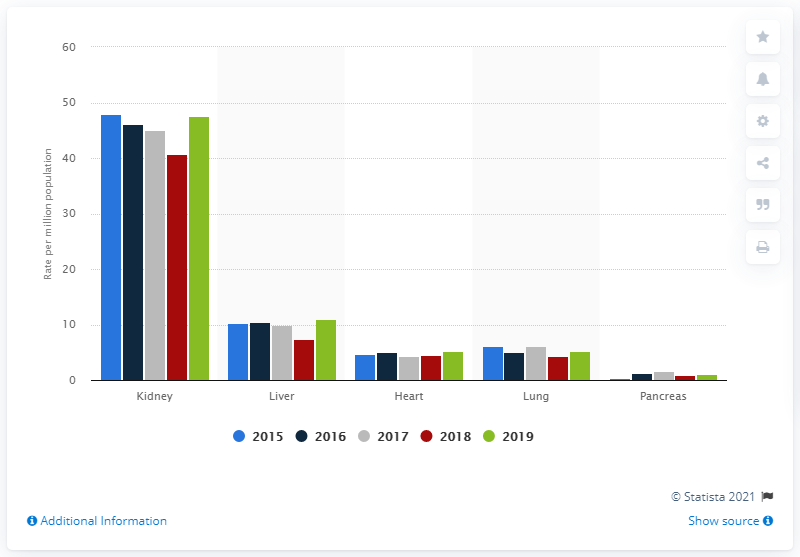Specify some key components in this picture. The second highest rate of kidney transplantation was observed in the liver. 